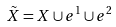Convert formula to latex. <formula><loc_0><loc_0><loc_500><loc_500>\tilde { X } = X \cup e ^ { 1 } \cup e ^ { 2 }</formula> 